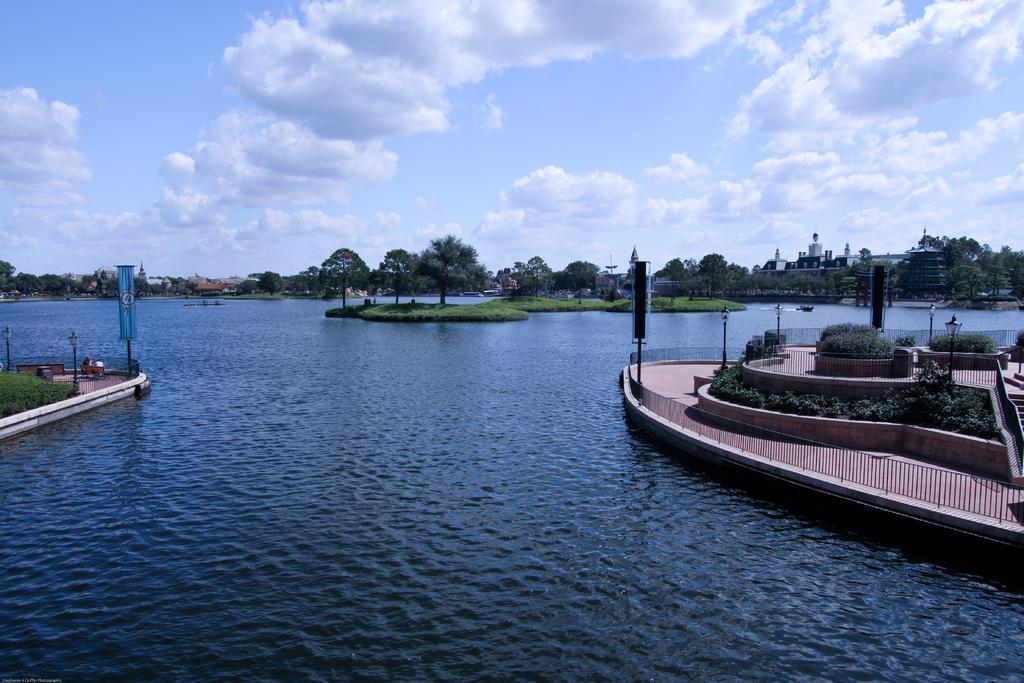Please provide a concise description of this image. On the left side, there are plants, lights attached to the poles, a banner attached to the pole on the platform. On the right side, there are plants, lights attached to the poles, banner attached to the pole and there are fencing on the platform. Between these two platforms, there is water. In the background, there are trees and grass on the ground, there are buildings and there are clouds in the blue sky. 